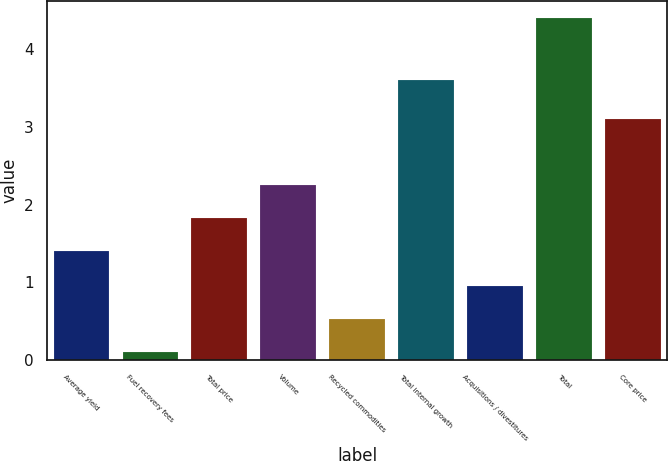Convert chart to OTSL. <chart><loc_0><loc_0><loc_500><loc_500><bar_chart><fcel>Average yield<fcel>Fuel recovery fees<fcel>Total price<fcel>Volume<fcel>Recycled commodities<fcel>Total internal growth<fcel>Acquisitions / divestitures<fcel>Total<fcel>Core price<nl><fcel>1.4<fcel>0.1<fcel>1.83<fcel>2.26<fcel>0.53<fcel>3.6<fcel>0.96<fcel>4.4<fcel>3.1<nl></chart> 